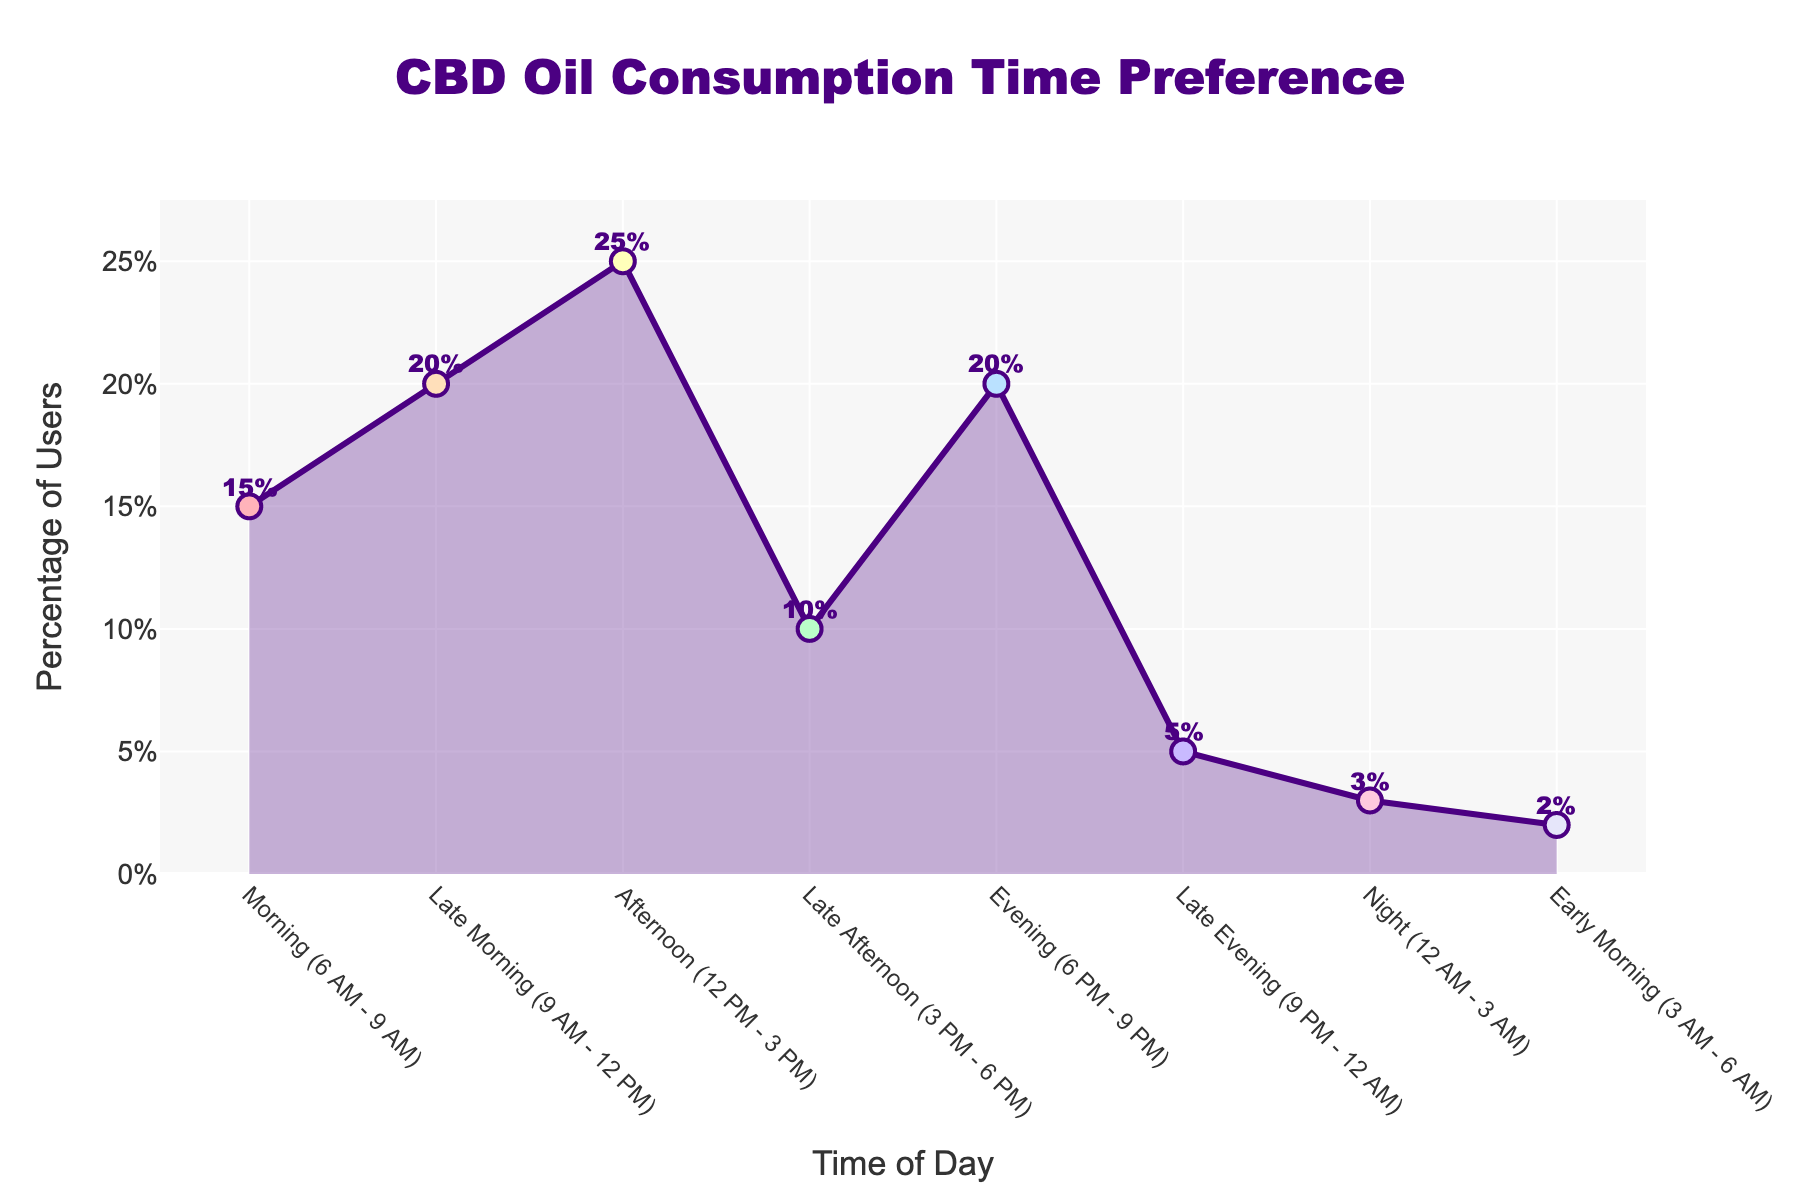What is the title of the figure? The figure's title is centered at the top and can be read directly.
Answer: CBD Oil Consumption Time Preference At what time of day do users most commonly consume CBD oil? By observing the highest peak in the plot, we can see that the Afternoon (12 PM - 3 PM) has the highest percentage.
Answer: Afternoon (12 PM - 3 PM) What percentage of users consume CBD oil in the Evening (6 PM - 9 PM)? The figure has an annotation for each data point, and the Evening (6 PM - 9 PM) time slot shows a value of 20%.
Answer: 20% Which time of day has the lowest percentage of CBD oil consumption? The lowest percentage can be identified by locating the smallest value on the y-axis. The Early Morning (3 AM - 6 AM) time slot has the lowest percentage at 2%.
Answer: Early Morning (3 AM - 6 AM) What is the combined percentage of users consuming CBD oil in the Late Evening (9 PM - 12 AM) and Night (12 AM - 3 AM)? By summing the percentages of the two time slots: Late Evening (5%) and Night (3%), we get 5% + 3% = 8%.
Answer: 8% How does the percentage of users consuming CBD oil in the Morning (6 AM - 9 AM) compare to that in the Late Afternoon (3 PM - 6 PM)? By comparing the two percentage values, Morning (15%) is higher than Late Afternoon (10%).
Answer: Morning (6 AM - 9 AM) is higher What is the range of percentages observed in the figure? The range is calculated by subtracting the smallest percentage from the largest percentage. The highest value is 25% (Afternoon), and the lowest is 2% (Early Morning), so the range is 25% - 2% = 23%.
Answer: 23% How much more common is CBD oil consumption in the Late Morning (9 AM - 12 PM) compared to the Early Morning (3 AM - 6 AM)? Subtract the percentage of the Early Morning (2%) from the Late Morning (20%), we get 20% - 2% = 18%.
Answer: 18% Given the variation in percentages throughout the day, what general trend can be observed in terms of CBD oil consumption preferences? A general trend can be observed that consumption tends to peak during typical waking hours, with a significant drop during early and late parts of the night. The distribution shows higher percentages from Morning to Evening and lower during late night/early morning hours.
Answer: Higher in waking hours, lower in late night/early morning 